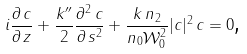<formula> <loc_0><loc_0><loc_500><loc_500>i \frac { \partial \, c } { \partial \, z } + \frac { k ^ { \prime \prime } } { 2 } \frac { \partial ^ { 2 } \, c } { \partial \, s ^ { 2 } } + \frac { k \, n _ { 2 } } { n _ { 0 } \mathcal { W } _ { 0 } ^ { 2 } } | c | ^ { 2 } \, c = 0 \text {,}</formula> 